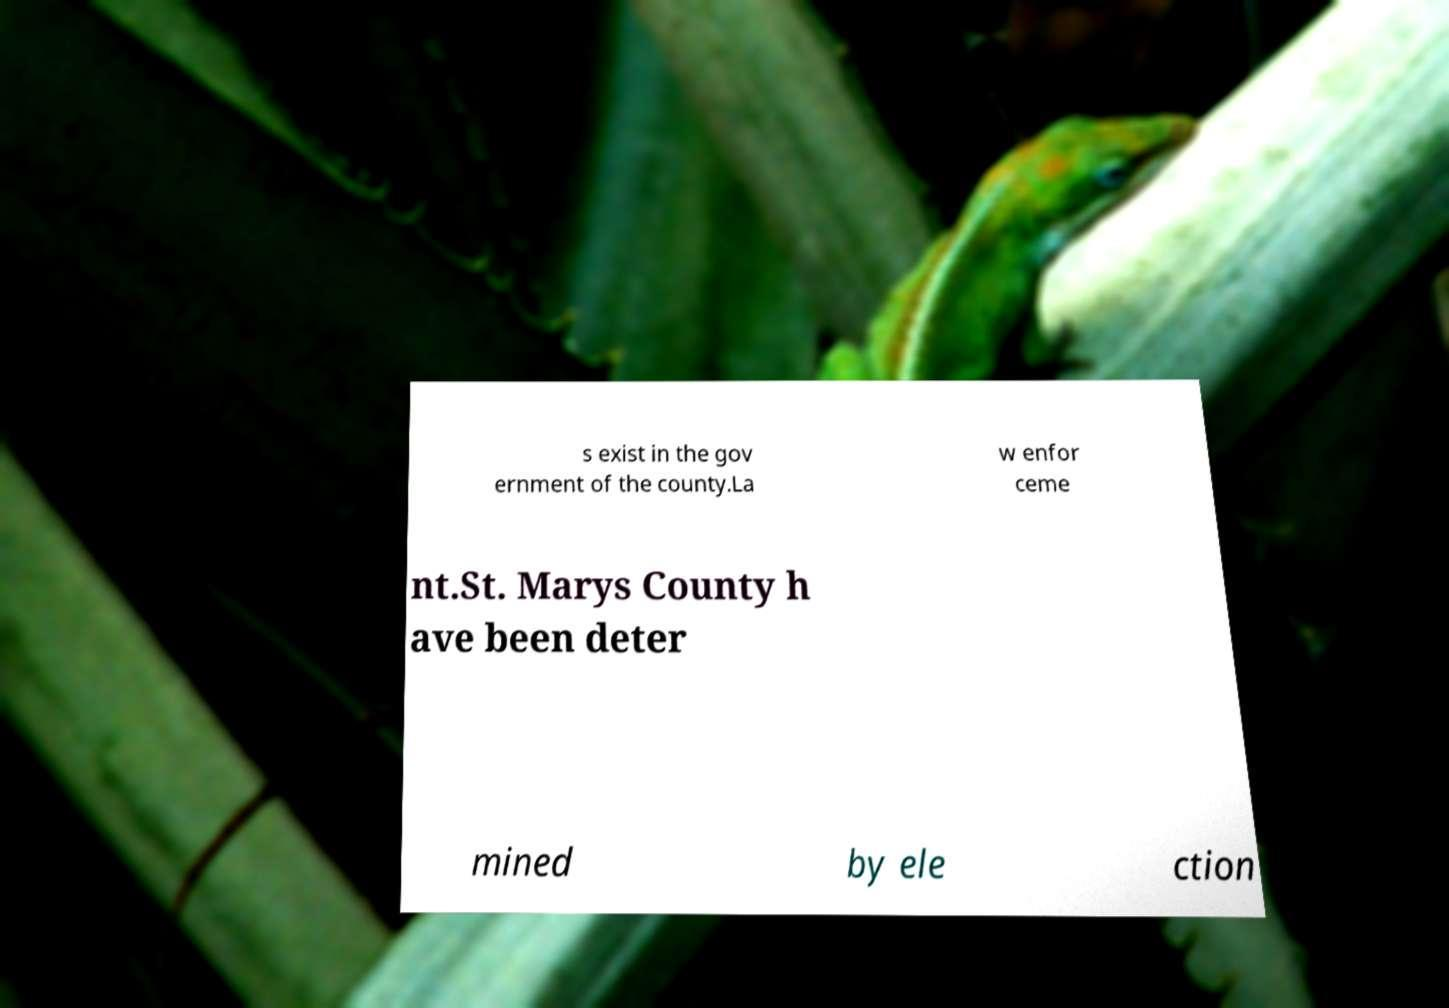Can you read and provide the text displayed in the image?This photo seems to have some interesting text. Can you extract and type it out for me? s exist in the gov ernment of the county.La w enfor ceme nt.St. Marys County h ave been deter mined by ele ction 